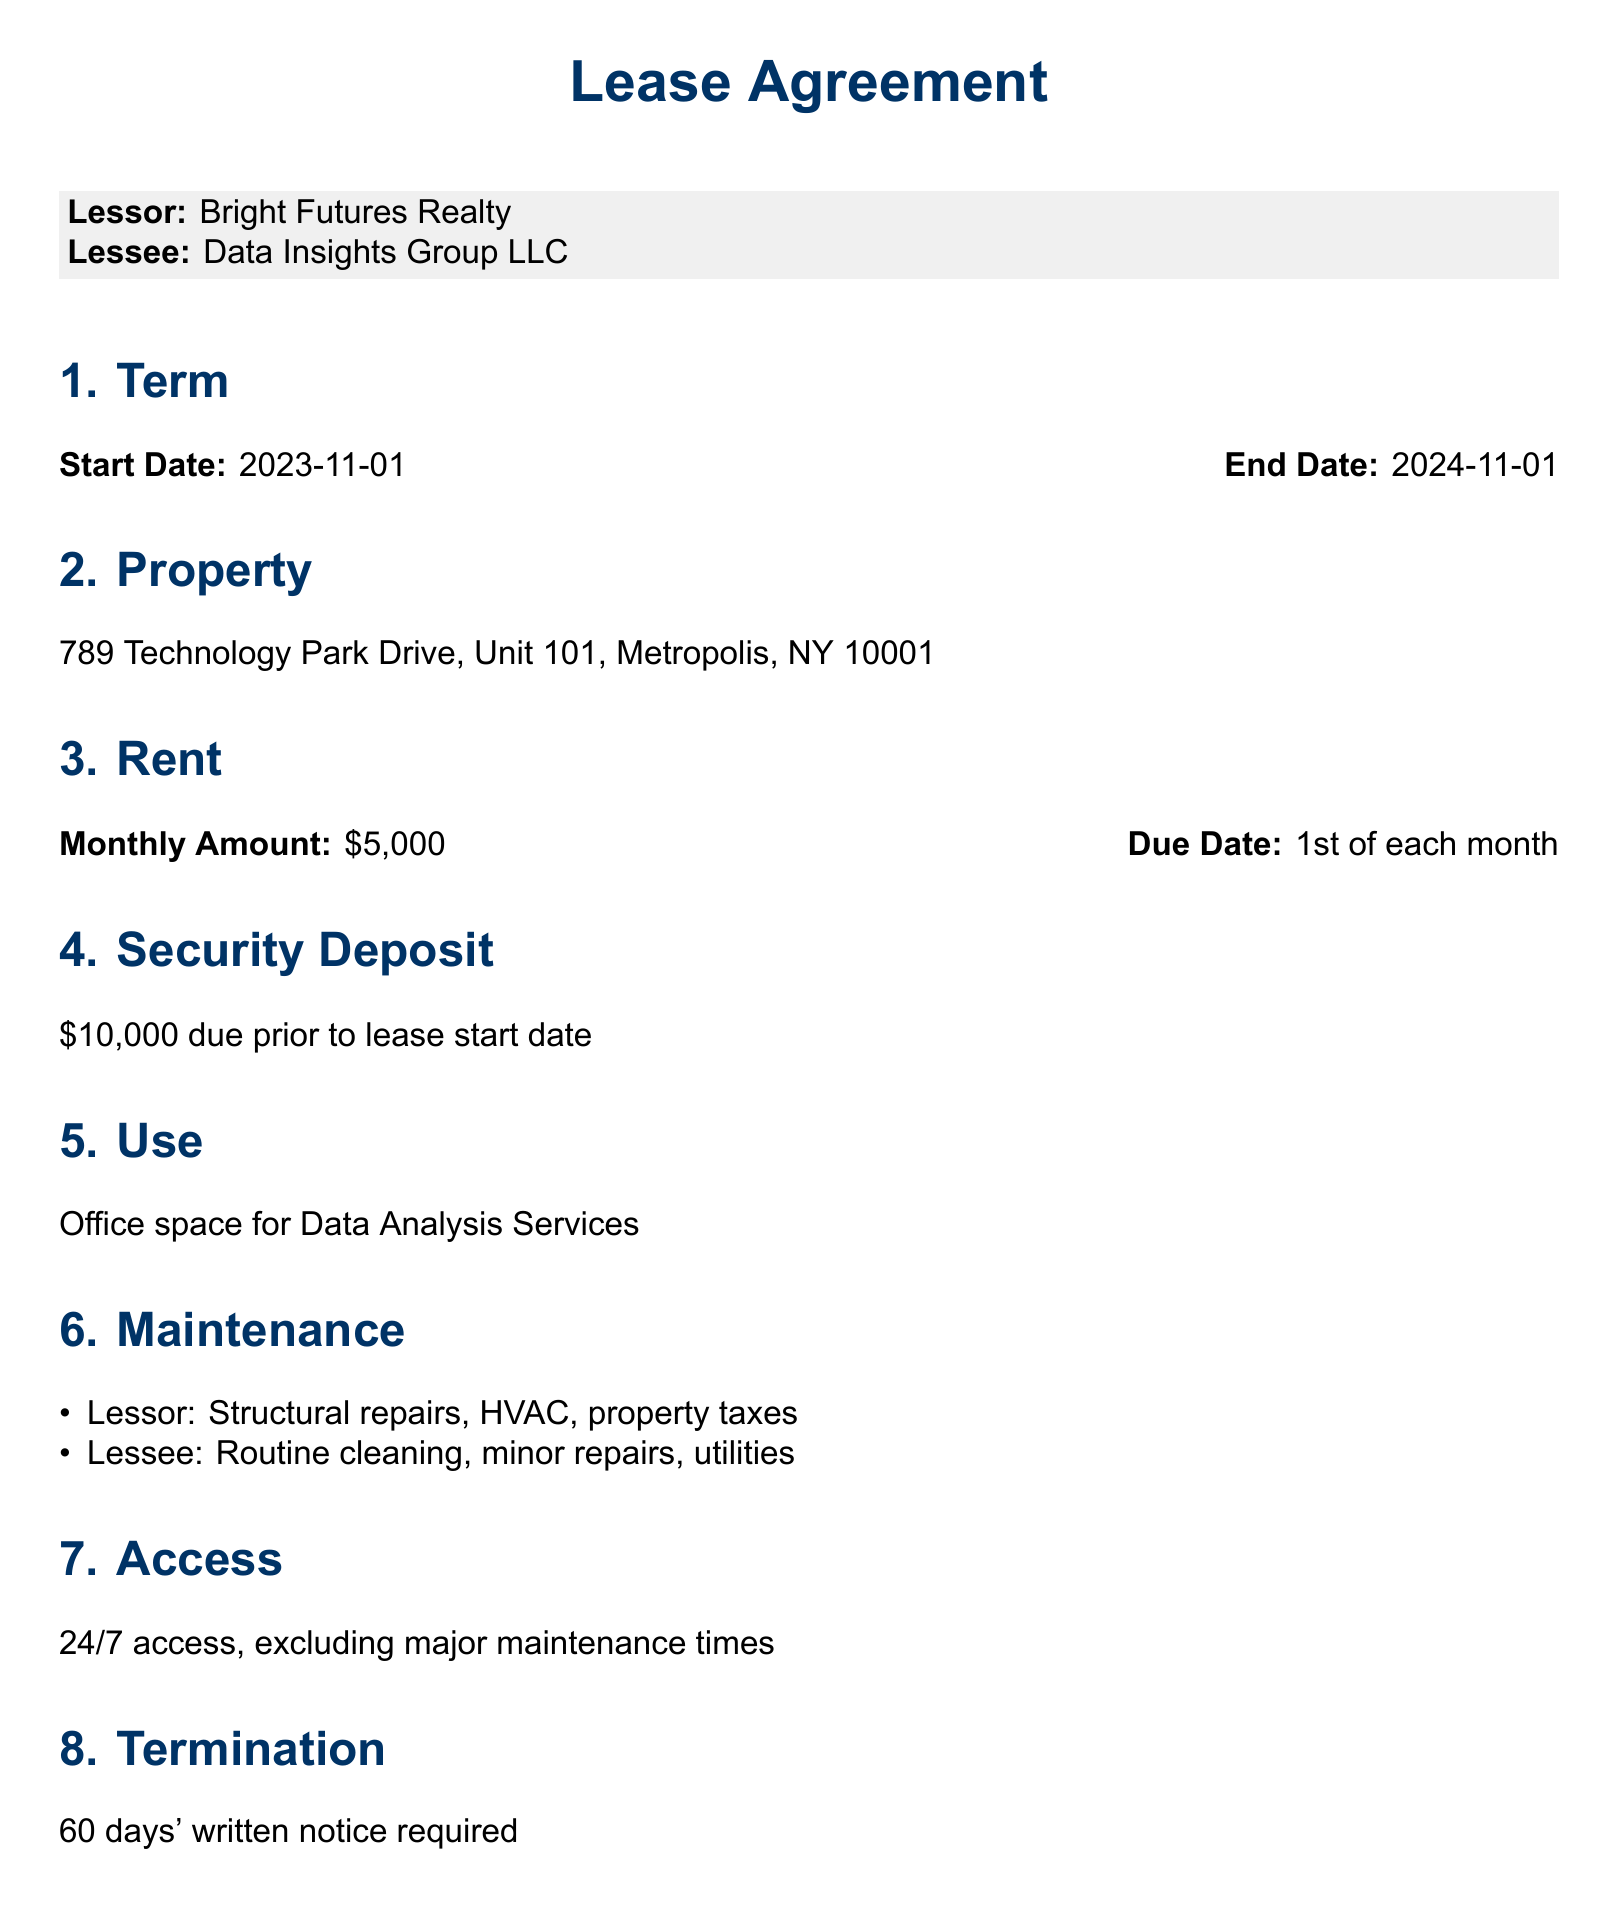What is the start date of the lease? The start date of the lease is specifically mentioned in the document under the "Term" section as the beginning date of the lease agreement.
Answer: 2023-11-01 What is the end date of the lease? The end date of the lease is specified in the "Term" section following the start date, denoting the conclusion of the lease agreement.
Answer: 2024-11-01 What is the monthly rent amount? The monthly rent amount is clearly outlined in the "Rent" section of the document stating the financial obligation of the lessee.
Answer: $5,000 What is the security deposit amount? The security deposit is mentioned in the "Security Deposit" section, indicating what the lessee must provide prior to moving in.
Answer: $10,000 What is the required notice period for termination? The required notice for termination is detailed in the "Termination" section, describing the process for ending the lease.
Answer: 60 days Who is responsible for routine cleaning? Responsibilities are clearly assigned in the "Maintenance" section, indicating which party handles specific maintenance tasks.
Answer: Lessee What is the purpose of the leased property? The use of the property is specified in the "Use" section, indicating its intended function under the lease agreement.
Answer: Office space for Data Analysis Services What are the conditions for subleasing? The conditions regarding subleasing are outlined in the "Additional Terms" section, emphasizing requirements needed before subleasing can occur.
Answer: Lessor's written consent How will disputes be resolved? The method for dispute resolution is described in the "Additional Terms," providing a clear approach in case conflicts arise.
Answer: Mediation, then arbitration 